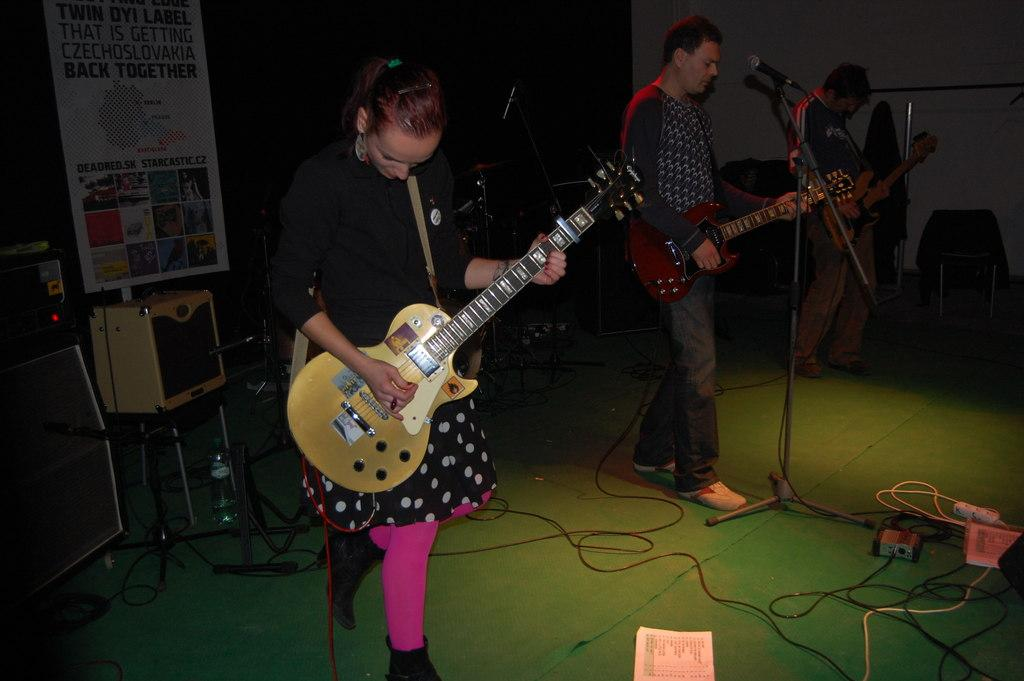What is the woman in the image doing? The woman is playing a guitar in the image. What is the woman wearing? The woman is wearing a black dress. How many other persons are in the image? There are two other persons in the image. What are the other two persons doing? The other two persons are also playing guitars. What object is present for amplifying sound? There is a microphone in the image. What type of chair is the woman sitting on while playing the guitar? There is no chair visible in the image; the woman is standing while playing the guitar. What color are the woman's teeth in the image? The woman's teeth are not visible in the image, so it cannot be determined what color they are. 